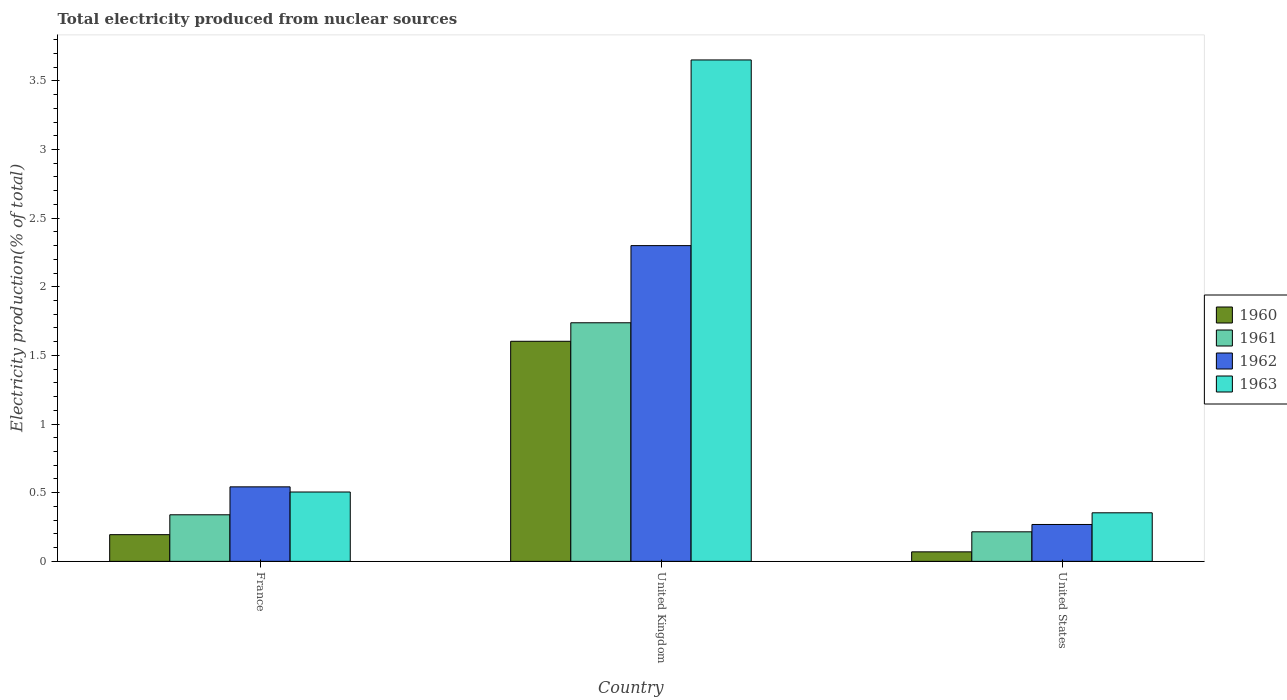How many different coloured bars are there?
Offer a terse response. 4. Are the number of bars on each tick of the X-axis equal?
Your response must be concise. Yes. In how many cases, is the number of bars for a given country not equal to the number of legend labels?
Give a very brief answer. 0. What is the total electricity produced in 1961 in France?
Make the answer very short. 0.34. Across all countries, what is the maximum total electricity produced in 1960?
Your answer should be compact. 1.6. Across all countries, what is the minimum total electricity produced in 1960?
Offer a terse response. 0.07. In which country was the total electricity produced in 1962 maximum?
Provide a short and direct response. United Kingdom. What is the total total electricity produced in 1963 in the graph?
Provide a short and direct response. 4.51. What is the difference between the total electricity produced in 1960 in United Kingdom and that in United States?
Offer a very short reply. 1.53. What is the difference between the total electricity produced in 1960 in United States and the total electricity produced in 1963 in United Kingdom?
Provide a succinct answer. -3.58. What is the average total electricity produced in 1960 per country?
Provide a short and direct response. 0.62. What is the difference between the total electricity produced of/in 1963 and total electricity produced of/in 1962 in United States?
Keep it short and to the point. 0.09. In how many countries, is the total electricity produced in 1960 greater than 1.4 %?
Provide a succinct answer. 1. What is the ratio of the total electricity produced in 1963 in France to that in United States?
Provide a succinct answer. 1.43. What is the difference between the highest and the second highest total electricity produced in 1963?
Make the answer very short. -3.15. What is the difference between the highest and the lowest total electricity produced in 1961?
Offer a very short reply. 1.52. In how many countries, is the total electricity produced in 1963 greater than the average total electricity produced in 1963 taken over all countries?
Provide a succinct answer. 1. Is the sum of the total electricity produced in 1961 in France and United Kingdom greater than the maximum total electricity produced in 1960 across all countries?
Offer a terse response. Yes. Is it the case that in every country, the sum of the total electricity produced in 1961 and total electricity produced in 1963 is greater than the sum of total electricity produced in 1962 and total electricity produced in 1960?
Offer a terse response. No. What does the 1st bar from the left in United States represents?
Keep it short and to the point. 1960. Is it the case that in every country, the sum of the total electricity produced in 1961 and total electricity produced in 1963 is greater than the total electricity produced in 1962?
Your answer should be very brief. Yes. Are all the bars in the graph horizontal?
Ensure brevity in your answer.  No. How many countries are there in the graph?
Keep it short and to the point. 3. Are the values on the major ticks of Y-axis written in scientific E-notation?
Give a very brief answer. No. Does the graph contain grids?
Your response must be concise. No. Where does the legend appear in the graph?
Give a very brief answer. Center right. How are the legend labels stacked?
Your answer should be very brief. Vertical. What is the title of the graph?
Provide a short and direct response. Total electricity produced from nuclear sources. Does "1986" appear as one of the legend labels in the graph?
Your answer should be compact. No. What is the label or title of the X-axis?
Keep it short and to the point. Country. What is the Electricity production(% of total) of 1960 in France?
Provide a short and direct response. 0.19. What is the Electricity production(% of total) in 1961 in France?
Make the answer very short. 0.34. What is the Electricity production(% of total) in 1962 in France?
Your answer should be very brief. 0.54. What is the Electricity production(% of total) in 1963 in France?
Your answer should be compact. 0.51. What is the Electricity production(% of total) of 1960 in United Kingdom?
Keep it short and to the point. 1.6. What is the Electricity production(% of total) of 1961 in United Kingdom?
Keep it short and to the point. 1.74. What is the Electricity production(% of total) of 1962 in United Kingdom?
Make the answer very short. 2.3. What is the Electricity production(% of total) in 1963 in United Kingdom?
Offer a very short reply. 3.65. What is the Electricity production(% of total) of 1960 in United States?
Give a very brief answer. 0.07. What is the Electricity production(% of total) in 1961 in United States?
Your answer should be compact. 0.22. What is the Electricity production(% of total) of 1962 in United States?
Keep it short and to the point. 0.27. What is the Electricity production(% of total) in 1963 in United States?
Your answer should be very brief. 0.35. Across all countries, what is the maximum Electricity production(% of total) of 1960?
Offer a terse response. 1.6. Across all countries, what is the maximum Electricity production(% of total) in 1961?
Make the answer very short. 1.74. Across all countries, what is the maximum Electricity production(% of total) of 1962?
Your answer should be compact. 2.3. Across all countries, what is the maximum Electricity production(% of total) in 1963?
Offer a terse response. 3.65. Across all countries, what is the minimum Electricity production(% of total) of 1960?
Offer a terse response. 0.07. Across all countries, what is the minimum Electricity production(% of total) in 1961?
Your answer should be very brief. 0.22. Across all countries, what is the minimum Electricity production(% of total) in 1962?
Ensure brevity in your answer.  0.27. Across all countries, what is the minimum Electricity production(% of total) of 1963?
Offer a terse response. 0.35. What is the total Electricity production(% of total) of 1960 in the graph?
Provide a succinct answer. 1.87. What is the total Electricity production(% of total) of 1961 in the graph?
Keep it short and to the point. 2.29. What is the total Electricity production(% of total) of 1962 in the graph?
Your answer should be compact. 3.11. What is the total Electricity production(% of total) in 1963 in the graph?
Provide a succinct answer. 4.51. What is the difference between the Electricity production(% of total) in 1960 in France and that in United Kingdom?
Your answer should be very brief. -1.41. What is the difference between the Electricity production(% of total) of 1961 in France and that in United Kingdom?
Ensure brevity in your answer.  -1.4. What is the difference between the Electricity production(% of total) of 1962 in France and that in United Kingdom?
Ensure brevity in your answer.  -1.76. What is the difference between the Electricity production(% of total) of 1963 in France and that in United Kingdom?
Your response must be concise. -3.15. What is the difference between the Electricity production(% of total) in 1960 in France and that in United States?
Provide a short and direct response. 0.13. What is the difference between the Electricity production(% of total) of 1961 in France and that in United States?
Your answer should be compact. 0.12. What is the difference between the Electricity production(% of total) in 1962 in France and that in United States?
Your answer should be compact. 0.27. What is the difference between the Electricity production(% of total) in 1963 in France and that in United States?
Make the answer very short. 0.15. What is the difference between the Electricity production(% of total) in 1960 in United Kingdom and that in United States?
Provide a succinct answer. 1.53. What is the difference between the Electricity production(% of total) of 1961 in United Kingdom and that in United States?
Give a very brief answer. 1.52. What is the difference between the Electricity production(% of total) of 1962 in United Kingdom and that in United States?
Give a very brief answer. 2.03. What is the difference between the Electricity production(% of total) of 1963 in United Kingdom and that in United States?
Your response must be concise. 3.3. What is the difference between the Electricity production(% of total) in 1960 in France and the Electricity production(% of total) in 1961 in United Kingdom?
Your answer should be compact. -1.54. What is the difference between the Electricity production(% of total) of 1960 in France and the Electricity production(% of total) of 1962 in United Kingdom?
Provide a succinct answer. -2.11. What is the difference between the Electricity production(% of total) of 1960 in France and the Electricity production(% of total) of 1963 in United Kingdom?
Your response must be concise. -3.46. What is the difference between the Electricity production(% of total) in 1961 in France and the Electricity production(% of total) in 1962 in United Kingdom?
Provide a succinct answer. -1.96. What is the difference between the Electricity production(% of total) in 1961 in France and the Electricity production(% of total) in 1963 in United Kingdom?
Your answer should be very brief. -3.31. What is the difference between the Electricity production(% of total) in 1962 in France and the Electricity production(% of total) in 1963 in United Kingdom?
Provide a short and direct response. -3.11. What is the difference between the Electricity production(% of total) of 1960 in France and the Electricity production(% of total) of 1961 in United States?
Keep it short and to the point. -0.02. What is the difference between the Electricity production(% of total) in 1960 in France and the Electricity production(% of total) in 1962 in United States?
Provide a succinct answer. -0.07. What is the difference between the Electricity production(% of total) in 1960 in France and the Electricity production(% of total) in 1963 in United States?
Offer a terse response. -0.16. What is the difference between the Electricity production(% of total) in 1961 in France and the Electricity production(% of total) in 1962 in United States?
Offer a terse response. 0.07. What is the difference between the Electricity production(% of total) of 1961 in France and the Electricity production(% of total) of 1963 in United States?
Your response must be concise. -0.01. What is the difference between the Electricity production(% of total) of 1962 in France and the Electricity production(% of total) of 1963 in United States?
Your answer should be very brief. 0.19. What is the difference between the Electricity production(% of total) in 1960 in United Kingdom and the Electricity production(% of total) in 1961 in United States?
Your answer should be compact. 1.39. What is the difference between the Electricity production(% of total) in 1960 in United Kingdom and the Electricity production(% of total) in 1962 in United States?
Your response must be concise. 1.33. What is the difference between the Electricity production(% of total) of 1960 in United Kingdom and the Electricity production(% of total) of 1963 in United States?
Your answer should be very brief. 1.25. What is the difference between the Electricity production(% of total) in 1961 in United Kingdom and the Electricity production(% of total) in 1962 in United States?
Your answer should be very brief. 1.47. What is the difference between the Electricity production(% of total) in 1961 in United Kingdom and the Electricity production(% of total) in 1963 in United States?
Your answer should be compact. 1.38. What is the difference between the Electricity production(% of total) of 1962 in United Kingdom and the Electricity production(% of total) of 1963 in United States?
Your response must be concise. 1.95. What is the average Electricity production(% of total) of 1960 per country?
Ensure brevity in your answer.  0.62. What is the average Electricity production(% of total) of 1961 per country?
Make the answer very short. 0.76. What is the average Electricity production(% of total) of 1963 per country?
Your answer should be compact. 1.5. What is the difference between the Electricity production(% of total) in 1960 and Electricity production(% of total) in 1961 in France?
Offer a very short reply. -0.14. What is the difference between the Electricity production(% of total) of 1960 and Electricity production(% of total) of 1962 in France?
Ensure brevity in your answer.  -0.35. What is the difference between the Electricity production(% of total) in 1960 and Electricity production(% of total) in 1963 in France?
Your response must be concise. -0.31. What is the difference between the Electricity production(% of total) in 1961 and Electricity production(% of total) in 1962 in France?
Offer a very short reply. -0.2. What is the difference between the Electricity production(% of total) of 1961 and Electricity production(% of total) of 1963 in France?
Give a very brief answer. -0.17. What is the difference between the Electricity production(% of total) in 1962 and Electricity production(% of total) in 1963 in France?
Your response must be concise. 0.04. What is the difference between the Electricity production(% of total) in 1960 and Electricity production(% of total) in 1961 in United Kingdom?
Your answer should be very brief. -0.13. What is the difference between the Electricity production(% of total) of 1960 and Electricity production(% of total) of 1962 in United Kingdom?
Offer a terse response. -0.7. What is the difference between the Electricity production(% of total) in 1960 and Electricity production(% of total) in 1963 in United Kingdom?
Your answer should be very brief. -2.05. What is the difference between the Electricity production(% of total) in 1961 and Electricity production(% of total) in 1962 in United Kingdom?
Offer a terse response. -0.56. What is the difference between the Electricity production(% of total) in 1961 and Electricity production(% of total) in 1963 in United Kingdom?
Offer a very short reply. -1.91. What is the difference between the Electricity production(% of total) in 1962 and Electricity production(% of total) in 1963 in United Kingdom?
Offer a terse response. -1.35. What is the difference between the Electricity production(% of total) of 1960 and Electricity production(% of total) of 1961 in United States?
Provide a succinct answer. -0.15. What is the difference between the Electricity production(% of total) in 1960 and Electricity production(% of total) in 1962 in United States?
Offer a very short reply. -0.2. What is the difference between the Electricity production(% of total) of 1960 and Electricity production(% of total) of 1963 in United States?
Give a very brief answer. -0.28. What is the difference between the Electricity production(% of total) in 1961 and Electricity production(% of total) in 1962 in United States?
Provide a short and direct response. -0.05. What is the difference between the Electricity production(% of total) of 1961 and Electricity production(% of total) of 1963 in United States?
Provide a succinct answer. -0.14. What is the difference between the Electricity production(% of total) of 1962 and Electricity production(% of total) of 1963 in United States?
Your answer should be very brief. -0.09. What is the ratio of the Electricity production(% of total) in 1960 in France to that in United Kingdom?
Offer a terse response. 0.12. What is the ratio of the Electricity production(% of total) in 1961 in France to that in United Kingdom?
Provide a short and direct response. 0.2. What is the ratio of the Electricity production(% of total) in 1962 in France to that in United Kingdom?
Give a very brief answer. 0.24. What is the ratio of the Electricity production(% of total) of 1963 in France to that in United Kingdom?
Make the answer very short. 0.14. What is the ratio of the Electricity production(% of total) of 1960 in France to that in United States?
Your response must be concise. 2.81. What is the ratio of the Electricity production(% of total) in 1961 in France to that in United States?
Give a very brief answer. 1.58. What is the ratio of the Electricity production(% of total) in 1962 in France to that in United States?
Provide a short and direct response. 2.02. What is the ratio of the Electricity production(% of total) of 1963 in France to that in United States?
Your answer should be compact. 1.43. What is the ratio of the Electricity production(% of total) of 1960 in United Kingdom to that in United States?
Offer a very short reply. 23.14. What is the ratio of the Electricity production(% of total) in 1961 in United Kingdom to that in United States?
Provide a succinct answer. 8.08. What is the ratio of the Electricity production(% of total) of 1962 in United Kingdom to that in United States?
Offer a very short reply. 8.56. What is the ratio of the Electricity production(% of total) in 1963 in United Kingdom to that in United States?
Make the answer very short. 10.32. What is the difference between the highest and the second highest Electricity production(% of total) of 1960?
Give a very brief answer. 1.41. What is the difference between the highest and the second highest Electricity production(% of total) of 1961?
Keep it short and to the point. 1.4. What is the difference between the highest and the second highest Electricity production(% of total) in 1962?
Keep it short and to the point. 1.76. What is the difference between the highest and the second highest Electricity production(% of total) of 1963?
Provide a short and direct response. 3.15. What is the difference between the highest and the lowest Electricity production(% of total) in 1960?
Give a very brief answer. 1.53. What is the difference between the highest and the lowest Electricity production(% of total) of 1961?
Offer a very short reply. 1.52. What is the difference between the highest and the lowest Electricity production(% of total) in 1962?
Make the answer very short. 2.03. What is the difference between the highest and the lowest Electricity production(% of total) of 1963?
Offer a very short reply. 3.3. 